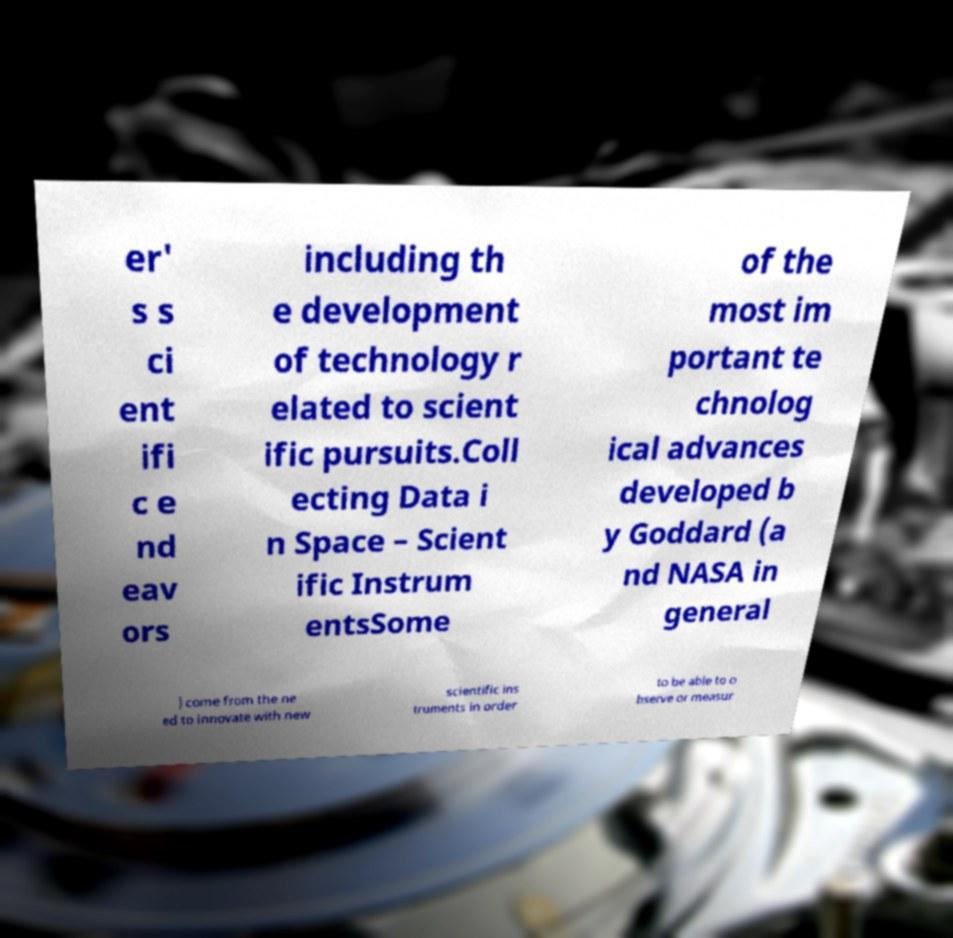There's text embedded in this image that I need extracted. Can you transcribe it verbatim? er' s s ci ent ifi c e nd eav ors including th e development of technology r elated to scient ific pursuits.Coll ecting Data i n Space – Scient ific Instrum entsSome of the most im portant te chnolog ical advances developed b y Goddard (a nd NASA in general ) come from the ne ed to innovate with new scientific ins truments in order to be able to o bserve or measur 